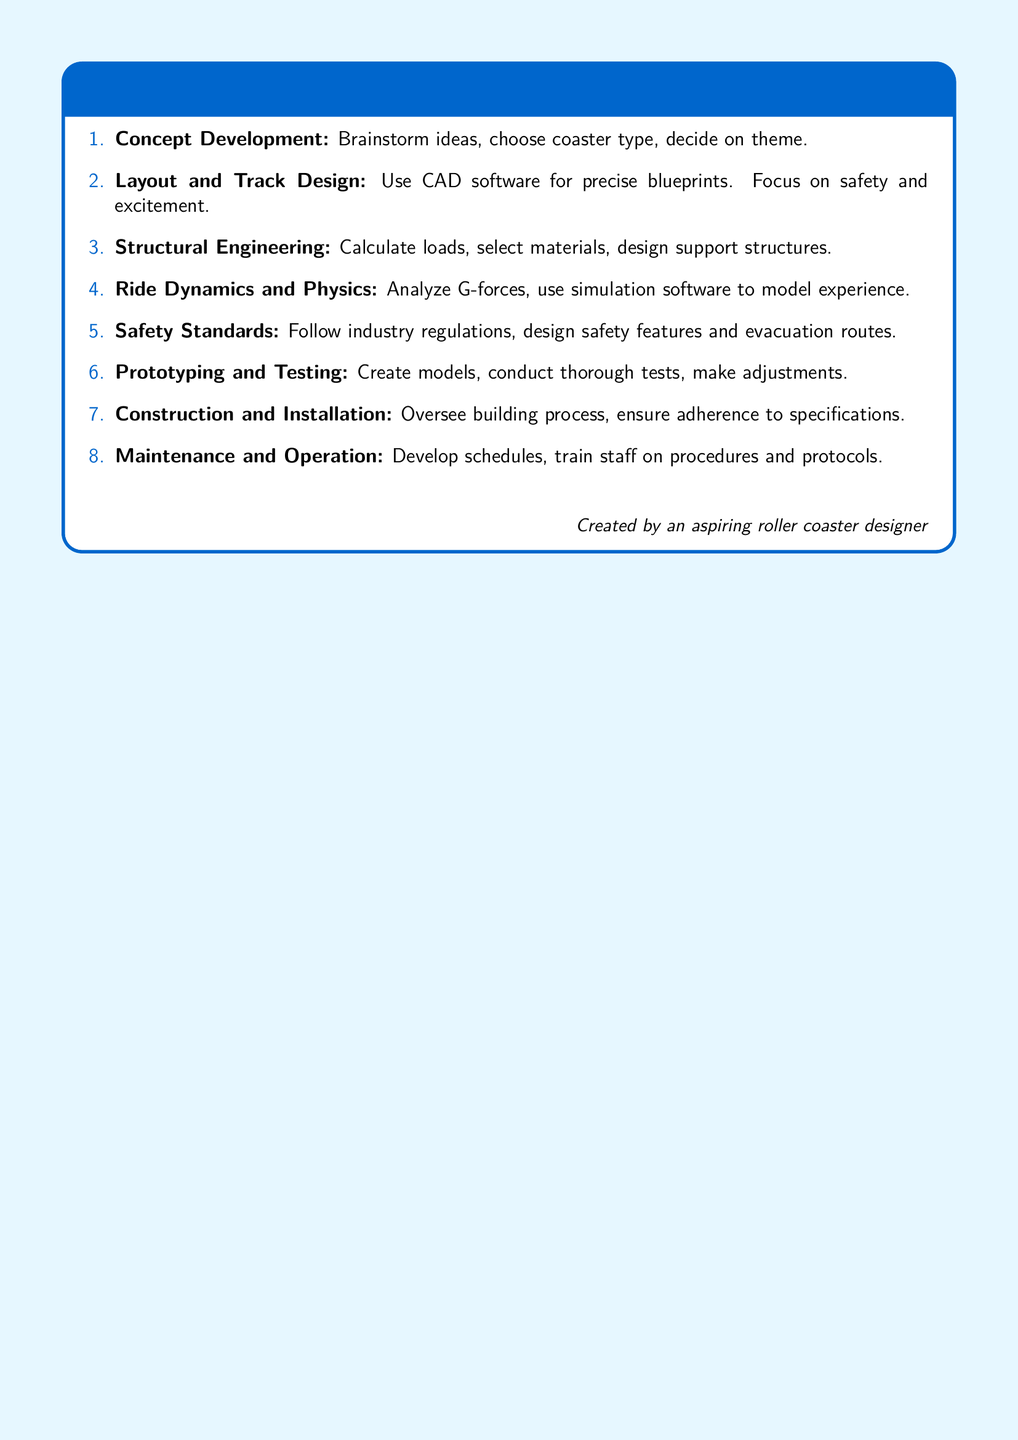What is the first step in roller coaster design? The first step is Concept Development, where ideas are brainstormed.
Answer: Concept Development How many steps are in the roller coaster design fundamentals? The document lists a total of eight steps in the roller coaster design process.
Answer: Eight What software is recommended for layout and track design? CAD software is suggested for creating precise blueprints.
Answer: CAD software What is crucial to focus on during layout and track design? Safety and excitement are critical focuses during this step.
Answer: Safety and excitement What type of engineering must be applied in roller coaster design? Structural Engineering principles must be applied to ensure the coaster's integrity.
Answer: Structural Engineering What analysis is vital in the Ride Dynamics and Physics step? Analyzing G-forces is essential to model the ride experience.
Answer: G-forces What do you need to follow when considering safety? Industry regulations must be adhered to when designing safety features.
Answer: Industry regulations What is involved in the Maintenance and Operation step? Developing schedules and training staff on procedures are key tasks in this step.
Answer: Developing schedules What phase comes after prototyping? Construction and Installation follow prototyping and testing.
Answer: Construction and Installation 